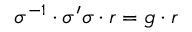<formula> <loc_0><loc_0><loc_500><loc_500>\sigma ^ { - 1 } \cdot \sigma ^ { \prime } \sigma \cdot r = g \cdot r</formula> 